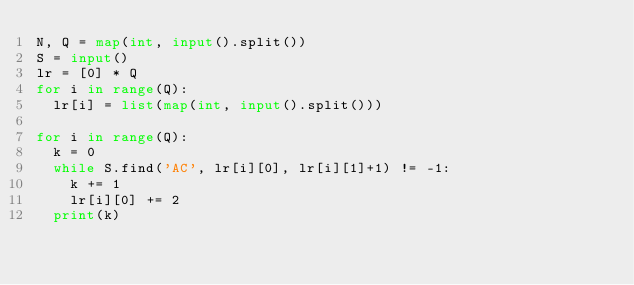Convert code to text. <code><loc_0><loc_0><loc_500><loc_500><_Python_>N, Q = map(int, input().split())
S = input()
lr = [0] * Q
for i in range(Q):
  lr[i] = list(map(int, input().split()))

for i in range(Q):  
  k = 0
  while S.find('AC', lr[i][0], lr[i][1]+1) != -1:
    k += 1
    lr[i][0] += 2
  print(k)</code> 